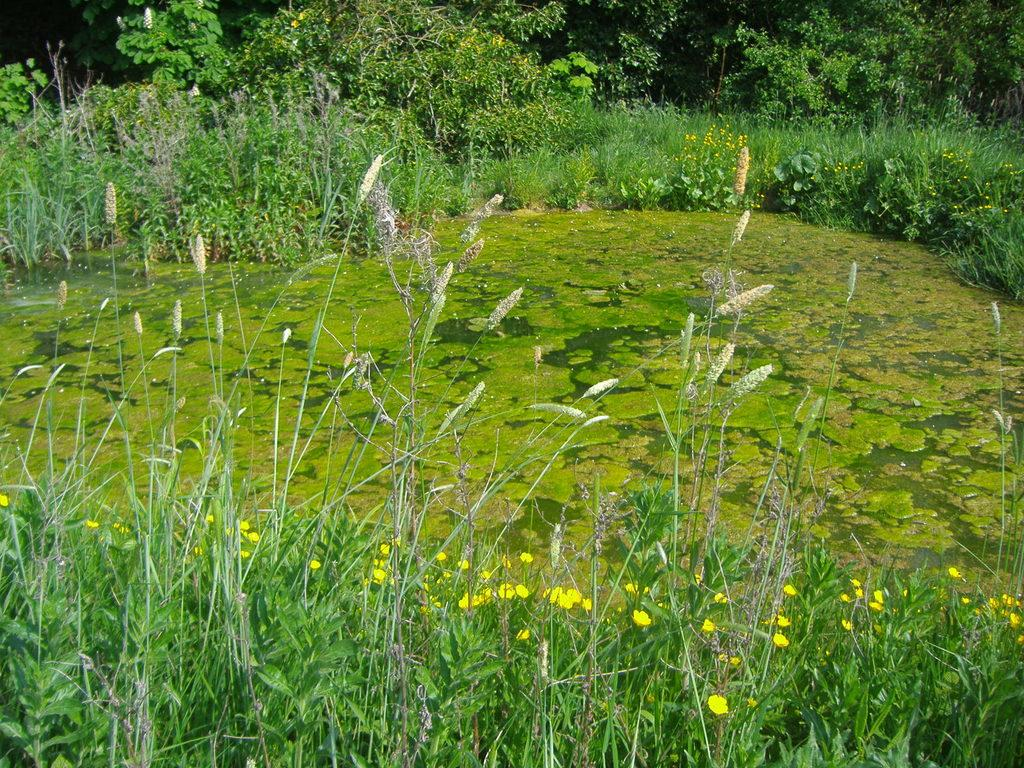What types of vegetation can be seen in the foreground of the picture? There are plants, grass, and flowers in the foreground of the picture. What is located in the middle of the picture? There is a water body in the middle of the picture. What types of vegetation can be seen at the top of the picture? There are plants, flowers, and trees at the top of the picture. What time does the clock show in the image? There is no clock present in the image. What type of poisonous substance can be seen in the image? There is no poisonous substance present in the image. 